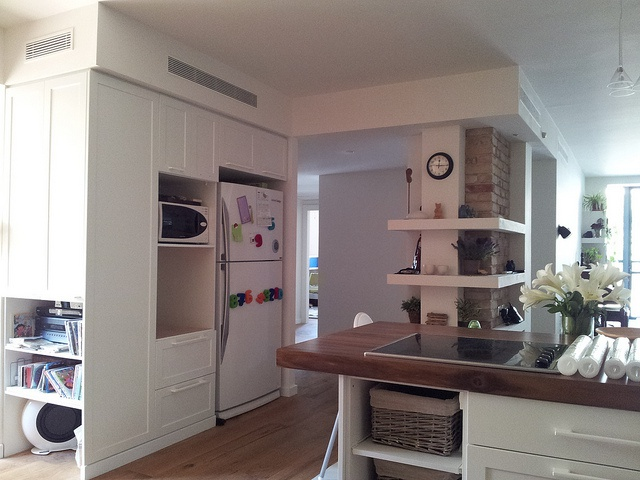Describe the objects in this image and their specific colors. I can see refrigerator in beige, gray, black, and maroon tones, oven in beige, gray, and black tones, potted plant in beige, darkgray, gray, black, and lightgray tones, microwave in beige, black, and gray tones, and potted plant in beige, darkgray, gray, and lightblue tones in this image. 